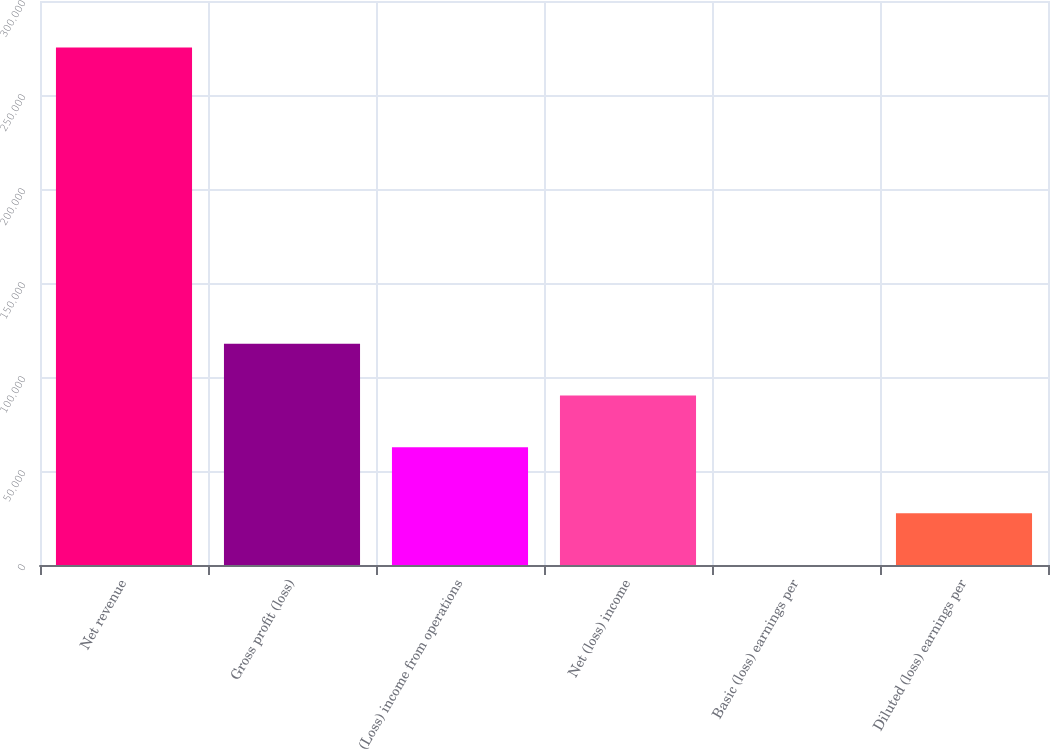Convert chart. <chart><loc_0><loc_0><loc_500><loc_500><bar_chart><fcel>Net revenue<fcel>Gross profit (loss)<fcel>(Loss) income from operations<fcel>Net (loss) income<fcel>Basic (loss) earnings per<fcel>Diluted (loss) earnings per<nl><fcel>275297<fcel>117696<fcel>62637<fcel>90166.6<fcel>0.81<fcel>27530.4<nl></chart> 